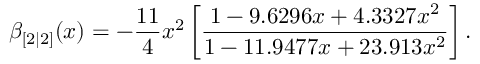Convert formula to latex. <formula><loc_0><loc_0><loc_500><loc_500>\beta _ { [ 2 | 2 ] } ( x ) = - \frac { 1 1 } { 4 } x ^ { 2 } \left [ \frac { 1 - 9 . 6 2 9 6 x + 4 . 3 3 2 7 x ^ { 2 } } { 1 - 1 1 . 9 4 7 7 x + 2 3 . 9 1 3 x ^ { 2 } } \right ] .</formula> 